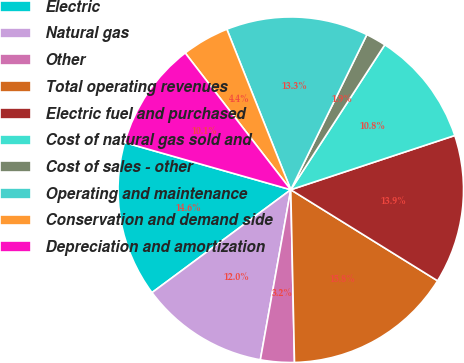<chart> <loc_0><loc_0><loc_500><loc_500><pie_chart><fcel>Electric<fcel>Natural gas<fcel>Other<fcel>Total operating revenues<fcel>Electric fuel and purchased<fcel>Cost of natural gas sold and<fcel>Cost of sales - other<fcel>Operating and maintenance<fcel>Conservation and demand side<fcel>Depreciation and amortization<nl><fcel>14.56%<fcel>12.03%<fcel>3.16%<fcel>15.82%<fcel>13.92%<fcel>10.76%<fcel>1.9%<fcel>13.29%<fcel>4.43%<fcel>10.13%<nl></chart> 